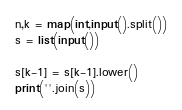<code> <loc_0><loc_0><loc_500><loc_500><_Python_>n,k = map(int,input().split())
s = list(input())

s[k-1] = s[k-1].lower()
print(''.join(s))</code> 